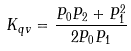<formula> <loc_0><loc_0><loc_500><loc_500>K _ { q v } = \frac { P _ { 0 } P _ { 2 } + P _ { 1 } ^ { 2 } } { 2 P _ { 0 } P _ { 1 } }</formula> 